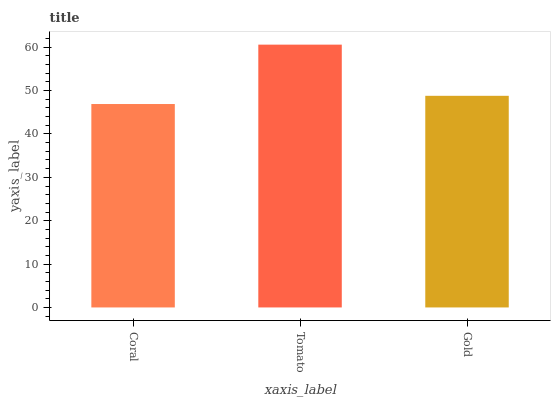Is Coral the minimum?
Answer yes or no. Yes. Is Tomato the maximum?
Answer yes or no. Yes. Is Gold the minimum?
Answer yes or no. No. Is Gold the maximum?
Answer yes or no. No. Is Tomato greater than Gold?
Answer yes or no. Yes. Is Gold less than Tomato?
Answer yes or no. Yes. Is Gold greater than Tomato?
Answer yes or no. No. Is Tomato less than Gold?
Answer yes or no. No. Is Gold the high median?
Answer yes or no. Yes. Is Gold the low median?
Answer yes or no. Yes. Is Tomato the high median?
Answer yes or no. No. Is Tomato the low median?
Answer yes or no. No. 